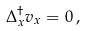<formula> <loc_0><loc_0><loc_500><loc_500>\Delta _ { x } ^ { \dagger } v _ { x } = 0 \, ,</formula> 